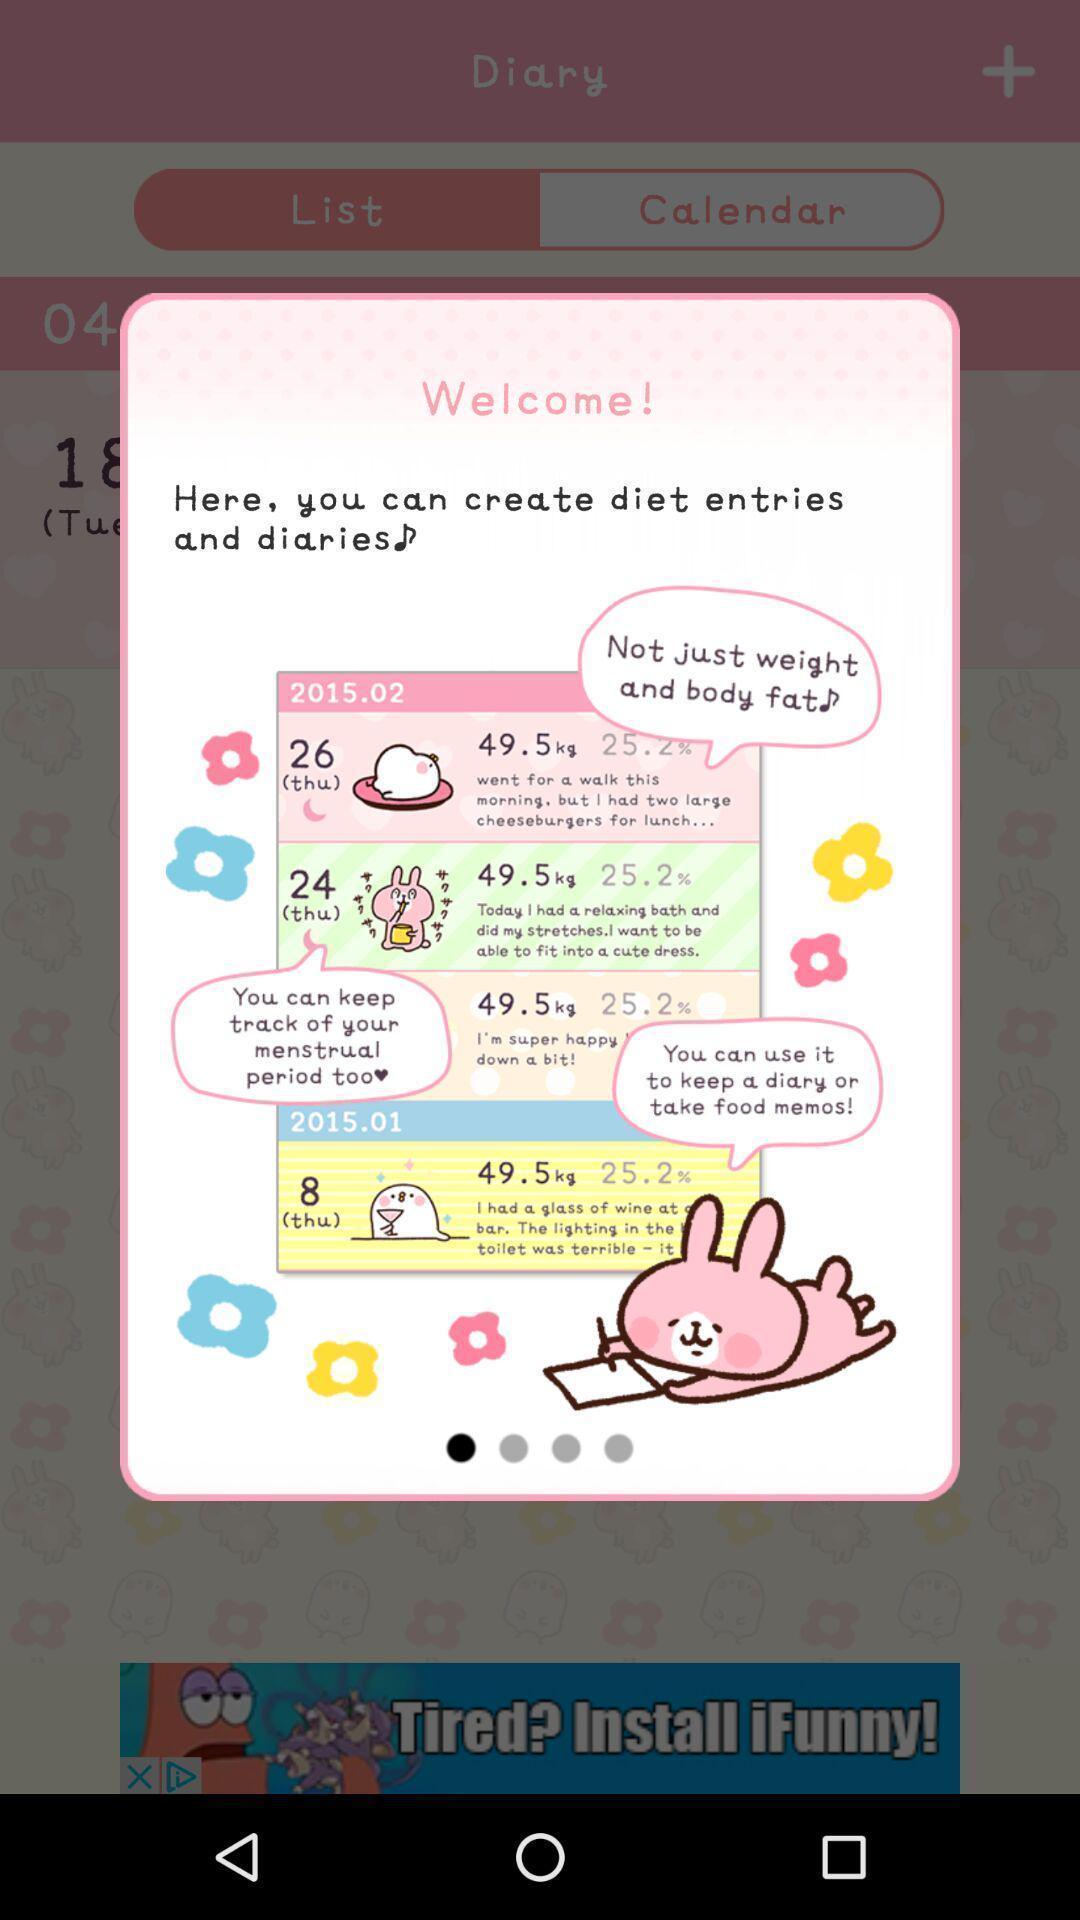Give me a summary of this screen capture. Welcome page for a weight tracking app. 